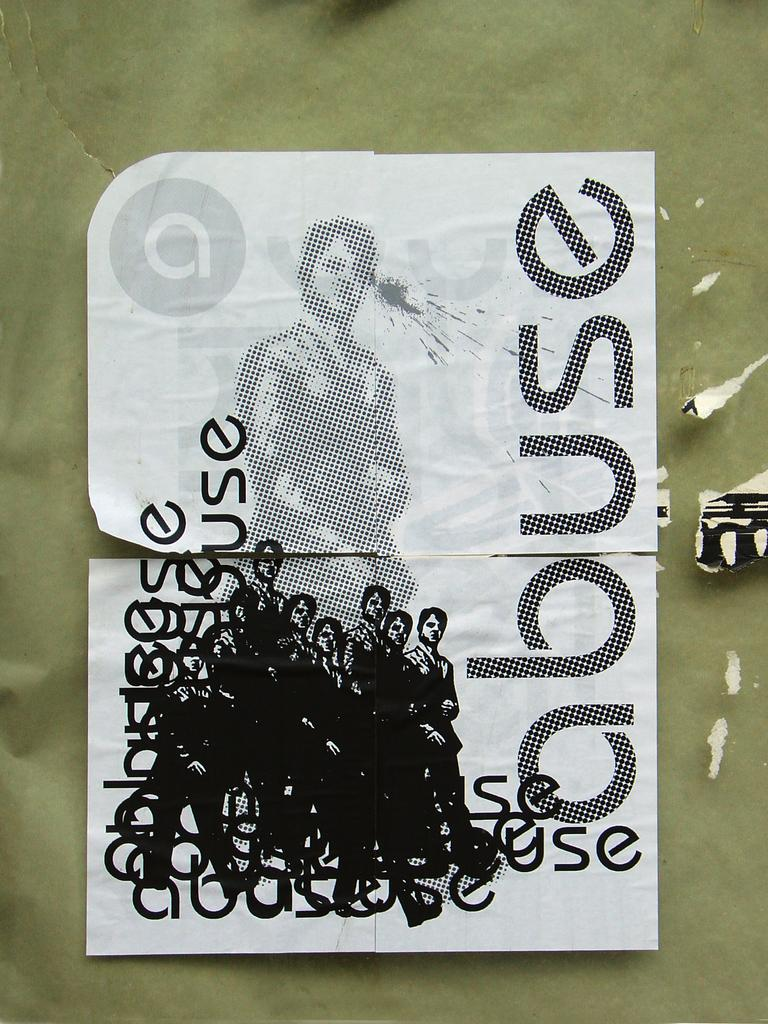What is present in the image that contains visual information? There is a poster in the image. What type of images can be seen on the poster? The poster contains pictures of a person. Is there any text on the poster? Yes, there is text on the poster. Can you tell me how many rivers are depicted on the poster? There are no rivers depicted on the poster; it contains pictures of a person and text. What type of calculator is shown being used by the person on the poster? There is no calculator present in the image; the poster contains pictures of a person and text. 